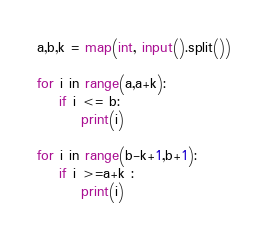<code> <loc_0><loc_0><loc_500><loc_500><_Python_>a,b,k = map(int, input().split())

for i in range(a,a+k):
    if i <= b:
        print(i)

for i in range(b-k+1,b+1):
    if i >=a+k :
        print(i)</code> 